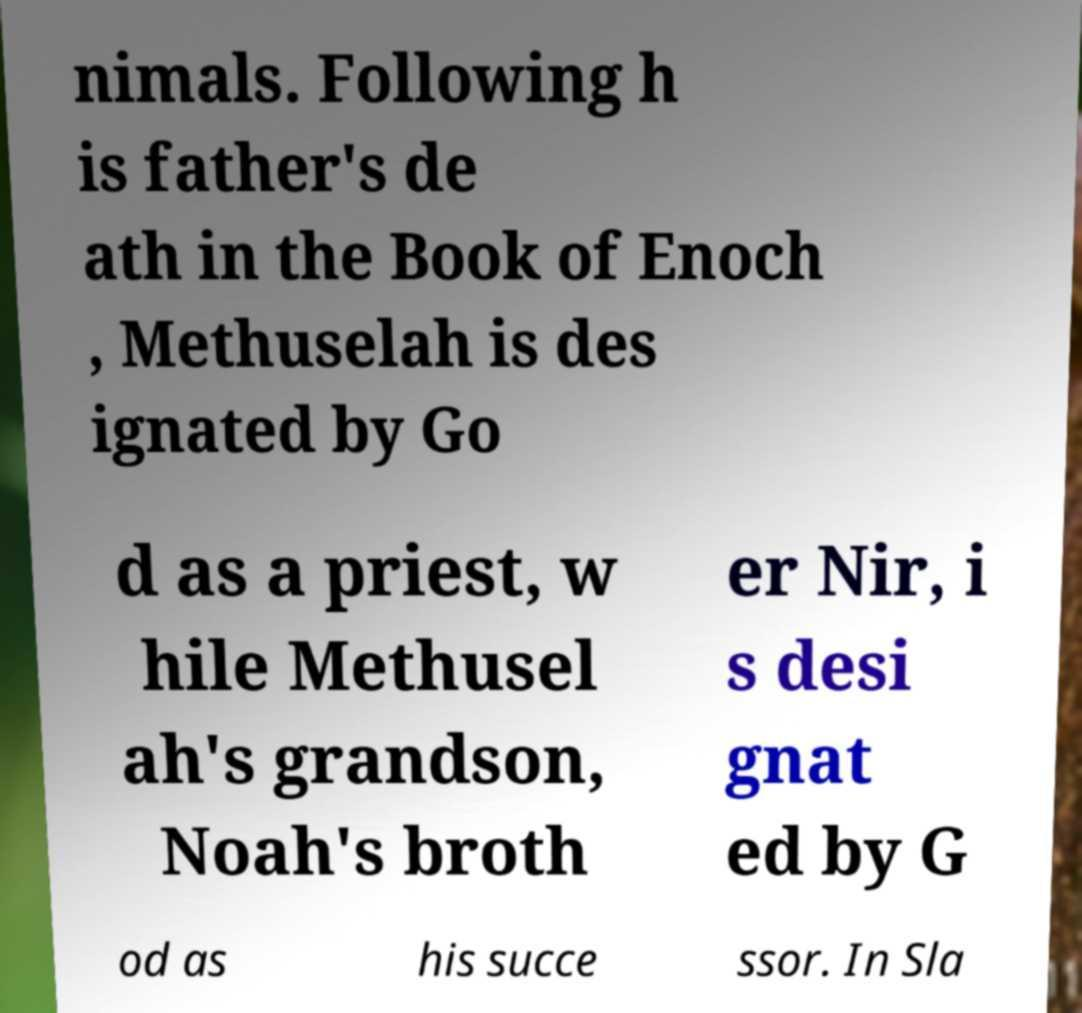Could you assist in decoding the text presented in this image and type it out clearly? nimals. Following h is father's de ath in the Book of Enoch , Methuselah is des ignated by Go d as a priest, w hile Methusel ah's grandson, Noah's broth er Nir, i s desi gnat ed by G od as his succe ssor. In Sla 